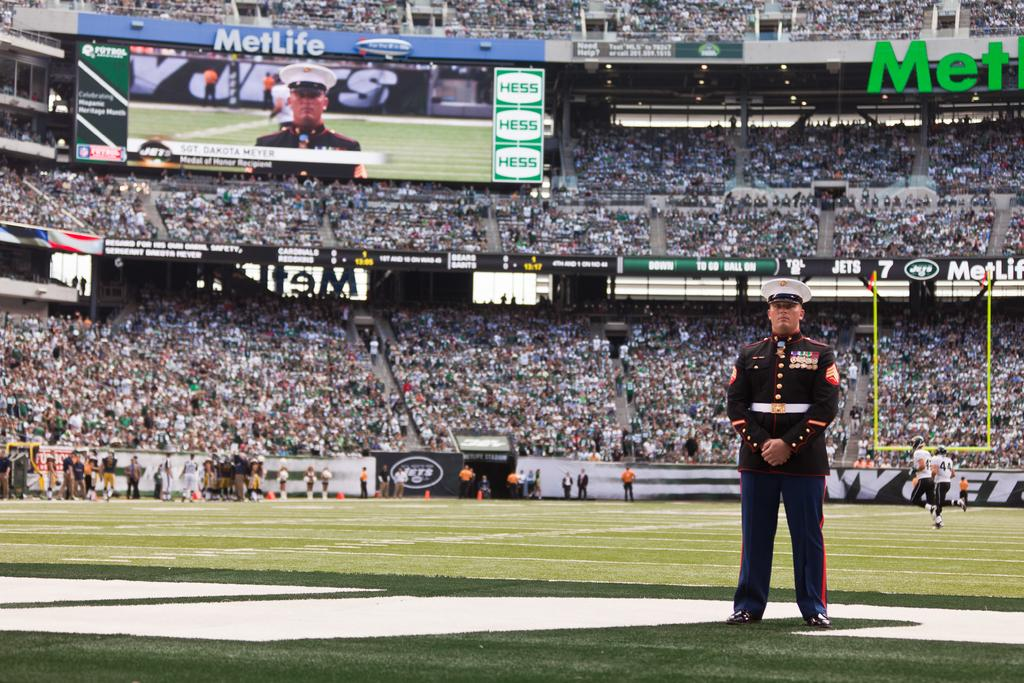Provide a one-sentence caption for the provided image. A Military Officer standing in the end zone at the New York Jets football stadium. 